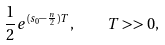<formula> <loc_0><loc_0><loc_500><loc_500>\frac { 1 } { 2 } e ^ { ( s _ { 0 } - \frac { n } { 2 } ) T } , \quad T > > 0 ,</formula> 